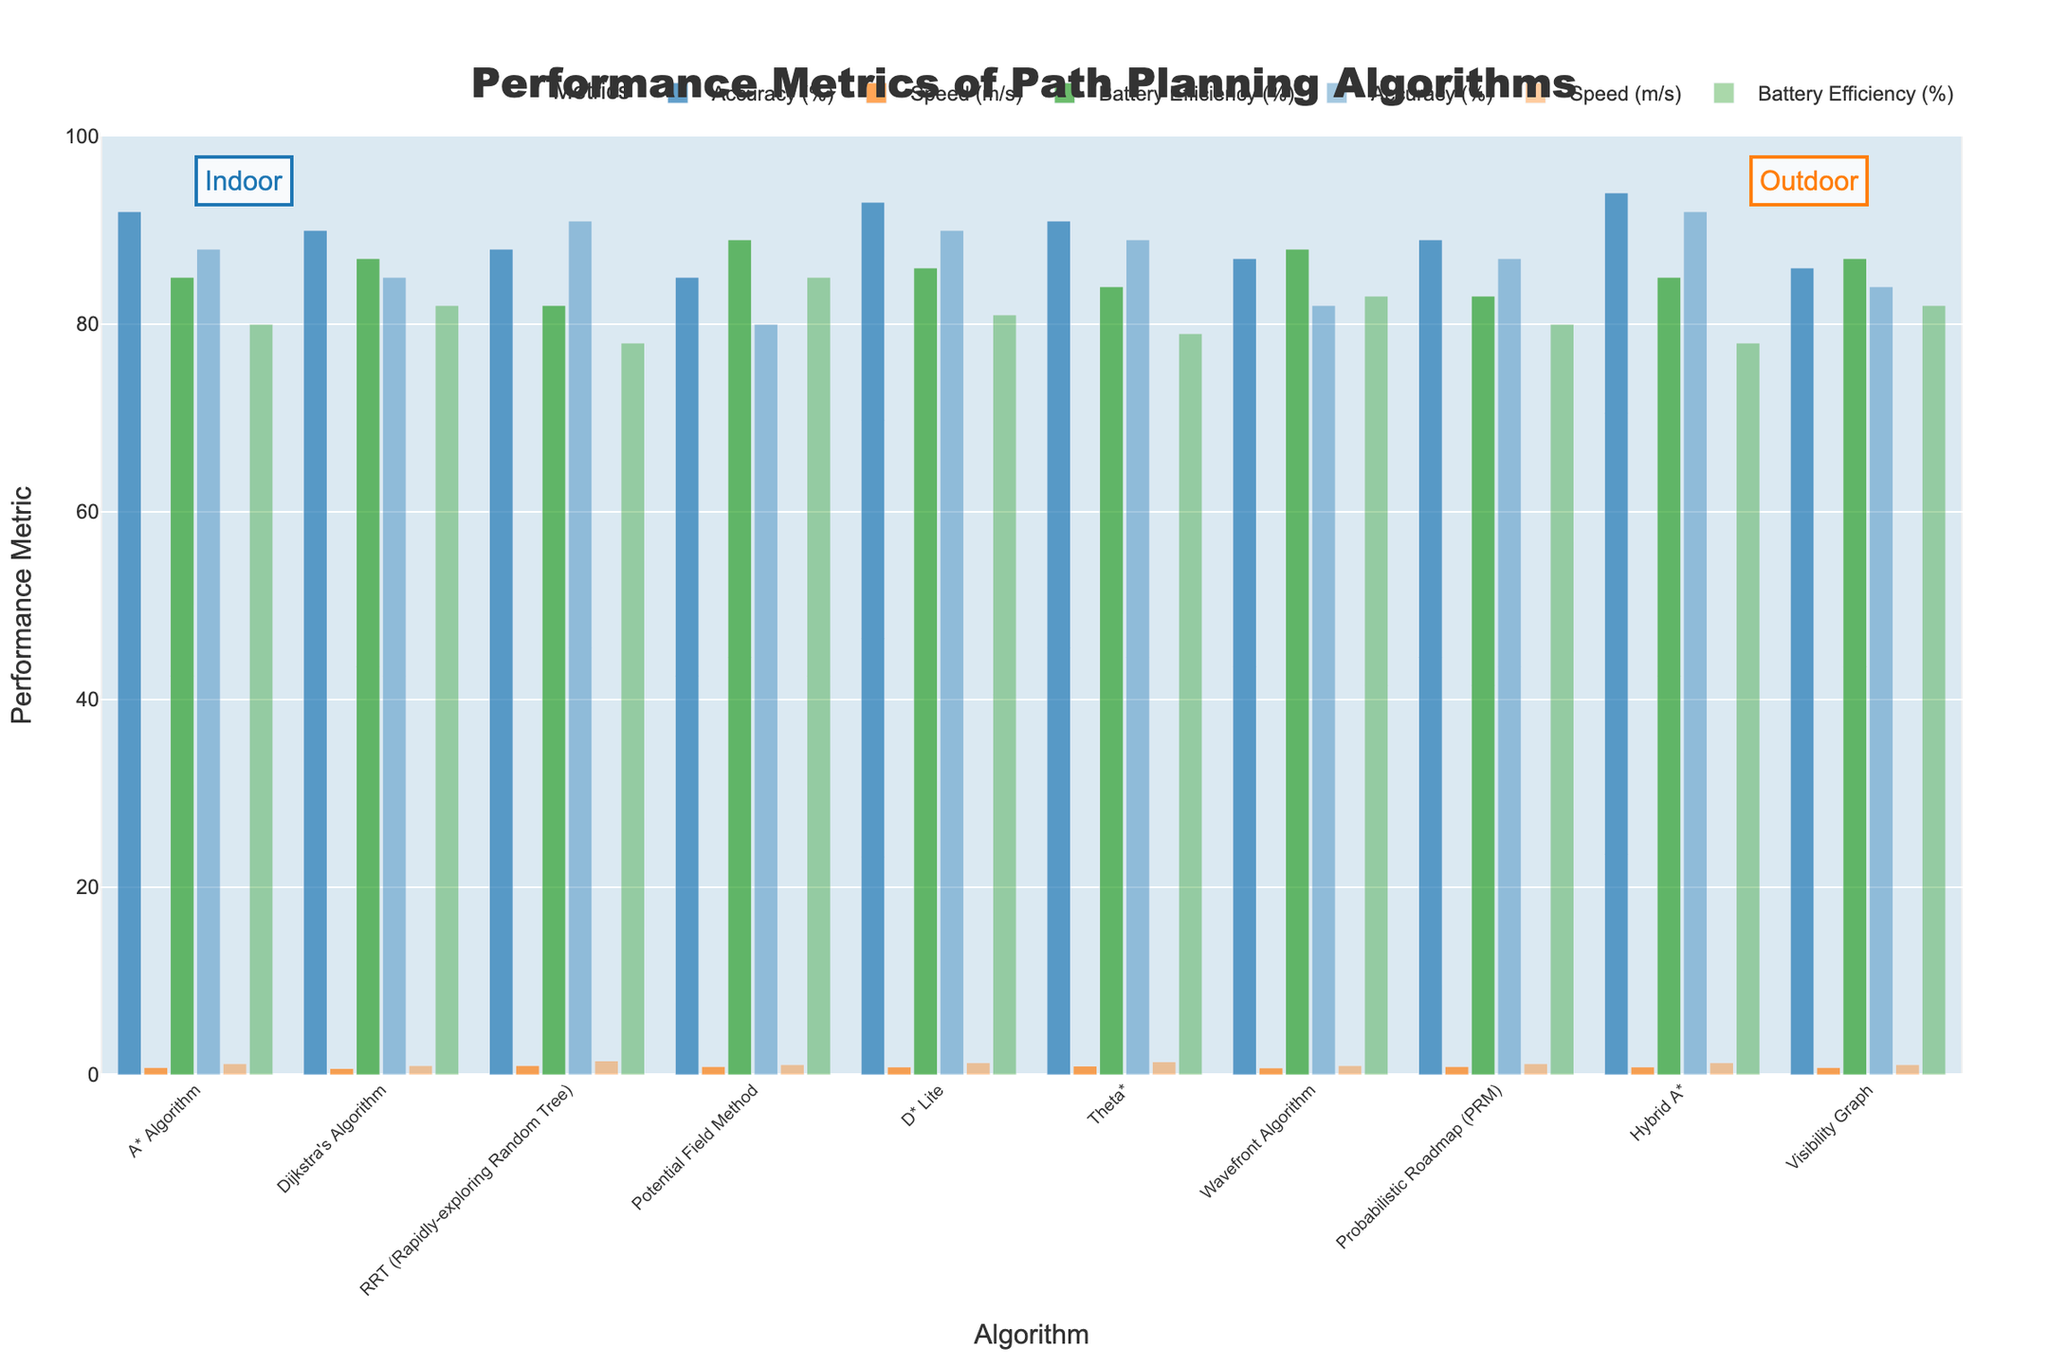Which algorithm has the highest indoor accuracy? By observing the heights of the bars corresponding to indoor accuracy for each algorithm, it's clear the highest bar is for Hybrid A*.
Answer: Hybrid A* How does the outdoor speed of RRT compare to the outdoor speed of Dijkstra's Algorithm? Looking at the heights of the outdoor speed bars, RRT's bar is higher than Dijkstra's. RRT has an outdoor speed of 1.5 m/s, while Dijkstra's is 1.0 m/s.
Answer: RRT is faster Which algorithm has the best indoor battery efficiency? Among the indoor battery efficiency bars, the highest bar represents the Potential Field Method with a value of 89%.
Answer: Potential Field Method What is the difference between the outdoor accuracy of A* Algorithm and D* Lite? The outdoor accuracy values can be found directly on the bars. A* Algorithm has 88%, and D* Lite has 90%. The difference is 90% - 88% = 2%.
Answer: 2% Which algorithm demonstrates the smallest difference in speed between indoor and outdoor environments? We need to calculate the absolute differences in speed for each algorithm. The smallest difference is for Potential Field Method, with indoor speed of 0.9 m/s and outdoor speed of 1.1 m/s, resulting in a difference of 0.2 m/s.
Answer: Potential Field Method Identify the algorithm with the highest outdoor battery efficiency and state its value. By inspecting the highest outdoor battery efficiency bar, Potential Field Method has the highest value at 85%.
Answer: Potential Field Method, 85% What is the average indoor accuracy of the A* Algorithm, Dijkstra's Algorithm, and Hybrid A*? Summing the indoor accuracy values of A* Algorithm (92%), Dijkstra's Algorithm (90%), and Hybrid A* (94%), we get 276%. Dividing by 3, the average is 276% / 3 = 92%.
Answer: 92% Which algorithm shows the largest decrease in accuracy from indoor to outdoor environments? We calculate the accuracy differences: A* Algorithm (4%), Dijkstra's (5%), RRT (-3%), Potential Field Method (5%), D* Lite (3%), Theta* (2%), Wavefront (5%), PRM (2%), Hybrid A* (2%), Visibility Graph (2%). The largest decrease is for Potential Field Method.
Answer: Potential Field Method How many algorithms have a higher indoor speed than outdoor speed? By checking each bar pair visually, only RRT has a higher indoor speed (1.0 m/s) compared to outdoor speed (1.5 m/s).
Answer: 1 Which two algorithms have identical indoor battery efficiency and what is the value? By examining the indoor battery efficiency bars, A* Algorithm and Hybrid A* both have a value of 85%.
Answer: A* Algorithm and Hybrid A*, 85% 